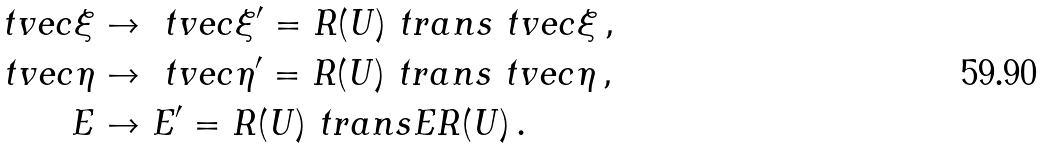Convert formula to latex. <formula><loc_0><loc_0><loc_500><loc_500>\ t v e c { \xi } & \to \ t v e c { \xi } ^ { \prime } = R ( U ) ^ { \ } t r a n s \ t v e c { \xi } \, , \\ \ t v e c { \eta } & \to \ t v e c { \eta } ^ { \prime } = R ( U ) ^ { \ } t r a n s \ t v e c { \eta } \, , \\ E & \to E ^ { \prime } = R ( U ) ^ { \ } t r a n s E R ( U ) \, .</formula> 